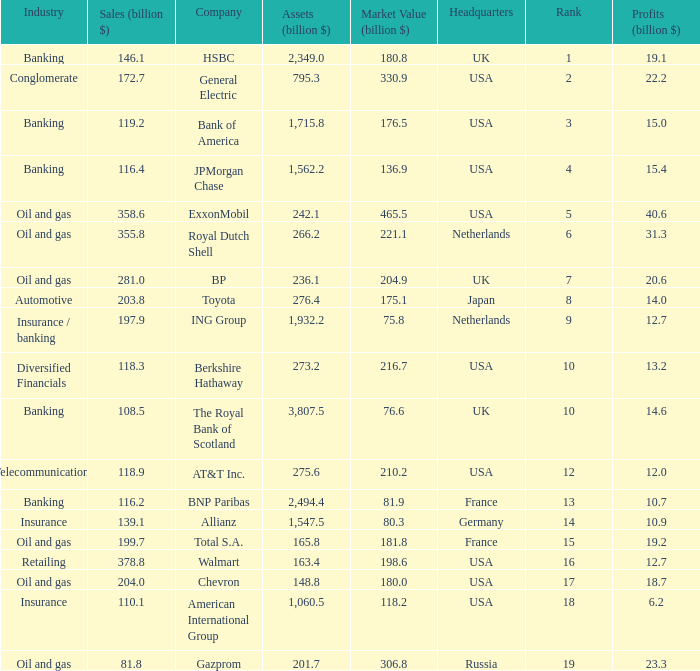What is the amount of profits in billions for companies with a market value of 204.9 billion?  20.6. 